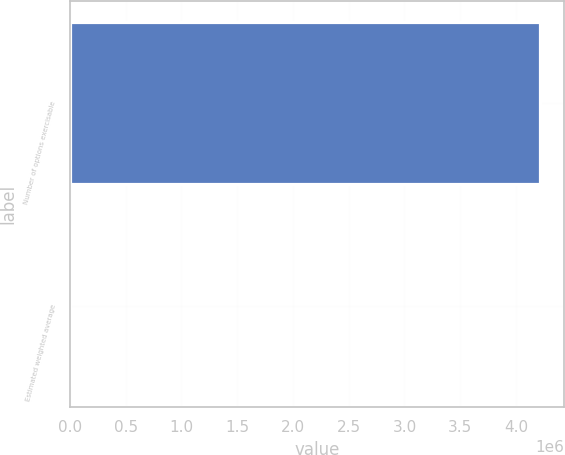Convert chart. <chart><loc_0><loc_0><loc_500><loc_500><bar_chart><fcel>Number of options exercisable<fcel>Estimated weighted average<nl><fcel>4.21956e+06<fcel>15.55<nl></chart> 